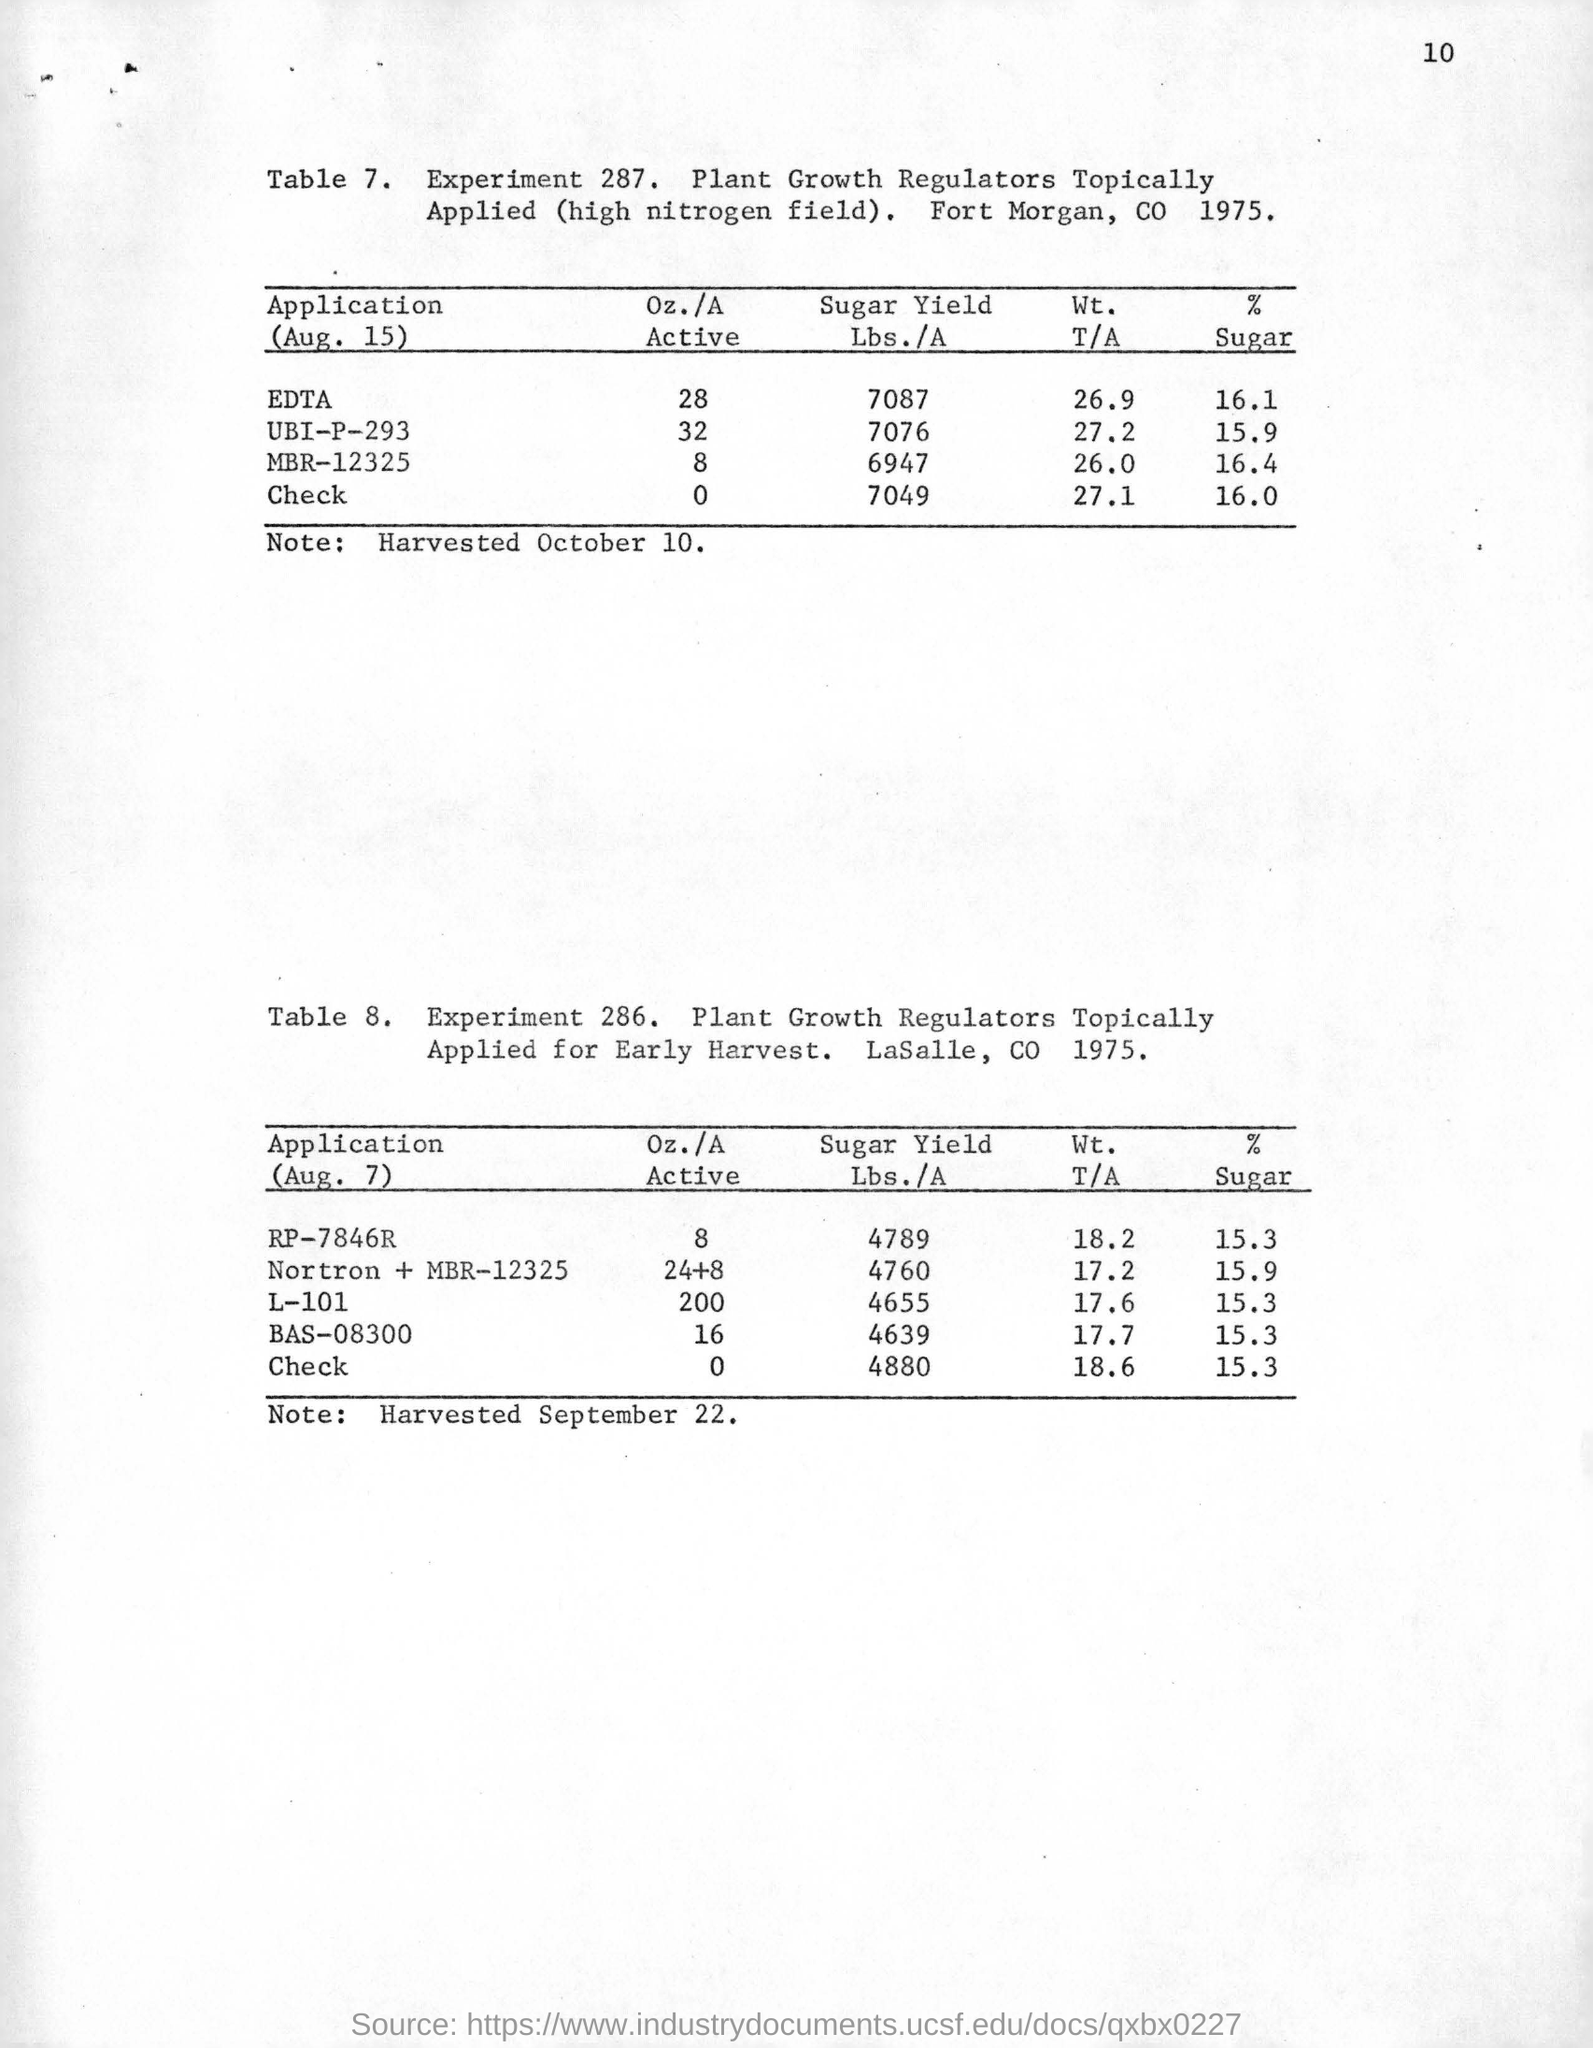What  is the sugar yield lbs./a for the application of edta at the rate of 16.1 sugar on aug 15?
Keep it short and to the point. 7087. What is the rate of sugar for the application of mbr-12325 on aug 15?
Ensure brevity in your answer.  16.4. What is experiment number of table 8 for plant growth regulators topically applied for early harvest?
Your response must be concise. 286. 